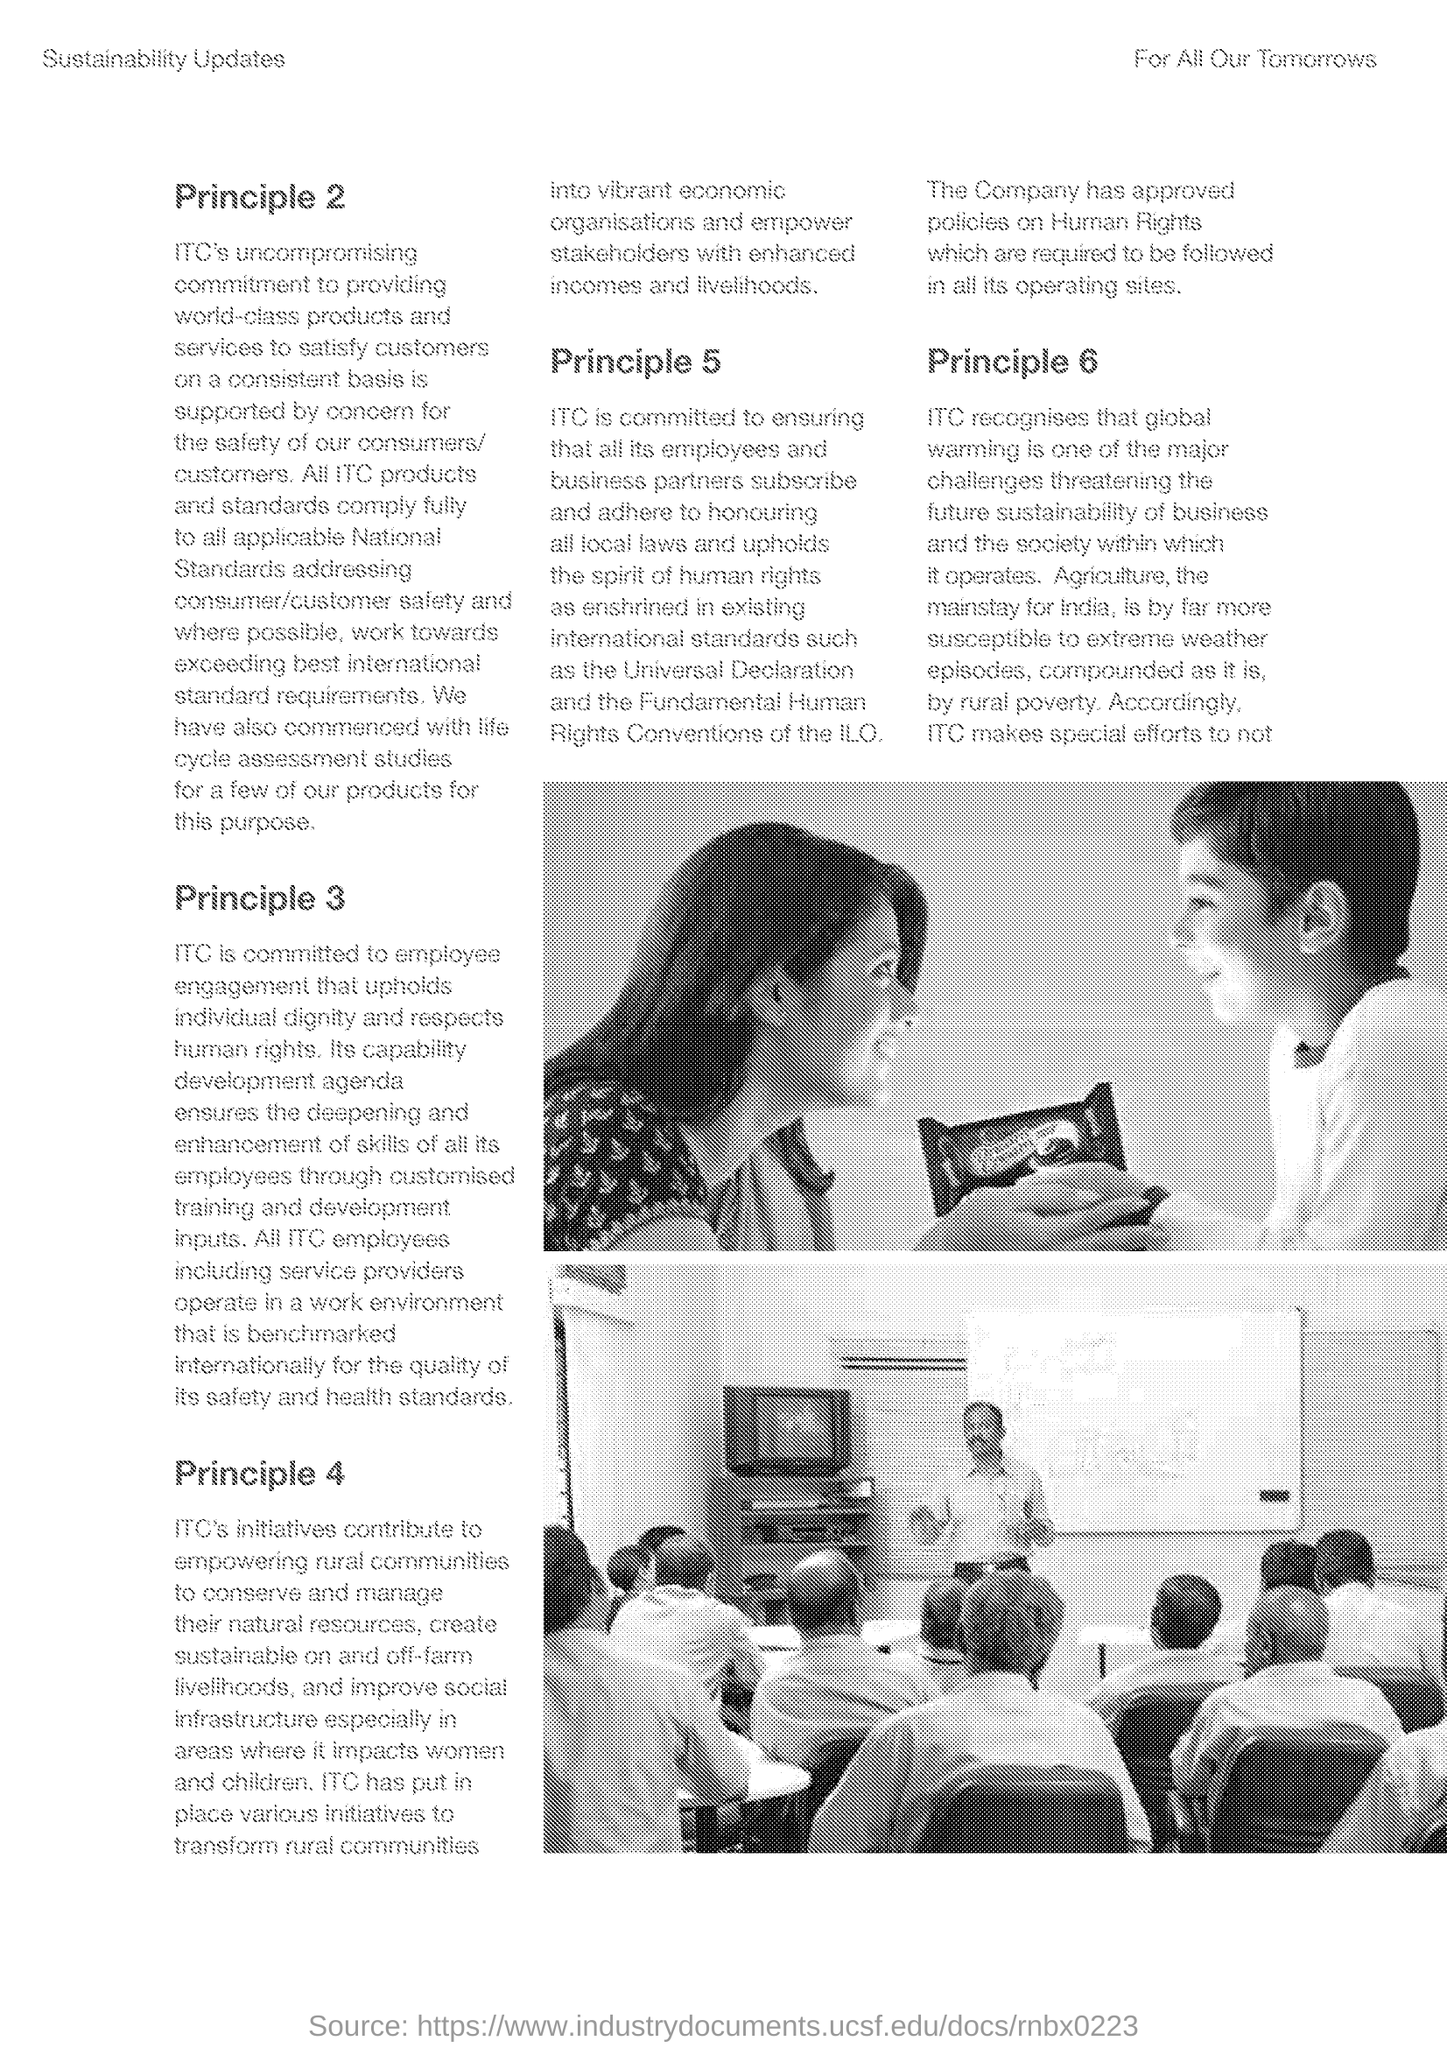Outline some significant characteristics in this image. Which is the last 'Principle' mentioned? PRINCIPLE 6. ITC has commenced ITC studies for some of its products, including LIFE CYCLE ASSESSMENT STUDIES. The first paragraph of the document explains Principle 2. According to Principle 3, ITC is committed to employee engagement. ITC's initiatives aim to empower rural communities through its contributions to various projects and initiatives. 